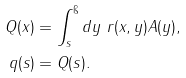<formula> <loc_0><loc_0><loc_500><loc_500>Q ( x ) & = \int _ { s } ^ { \i } d y \ r ( x , y ) A ( y ) , \\ q ( s ) & = Q ( s ) .</formula> 